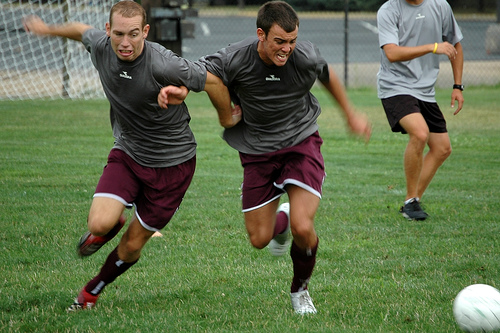<image>
Can you confirm if the shoe is in front of the net? No. The shoe is not in front of the net. The spatial positioning shows a different relationship between these objects. 